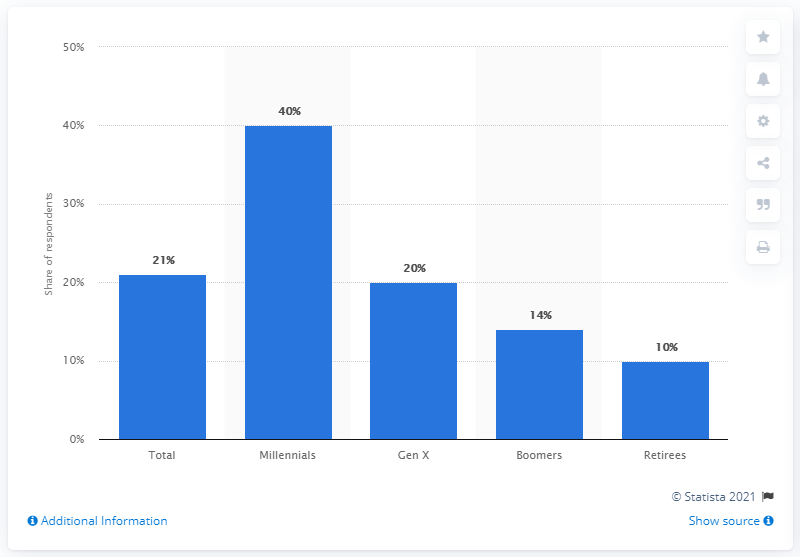Give some essential details in this illustration. According to a survey conducted in January 2017, a significant percentage of retirees who subscribed to music service subscriptions had had a subscription to the service at that time. 